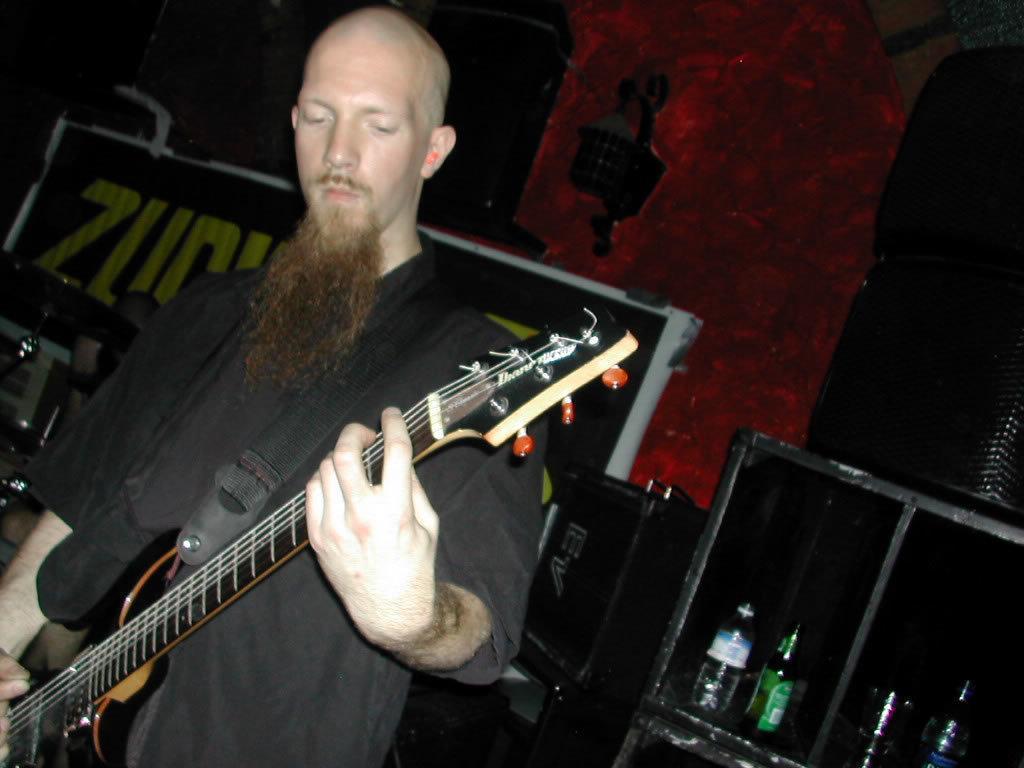Describe this image in one or two sentences. A man with black t-shirt is standing and playing a guitar. To the right bottom there is a cupboard with bottles in it. On the cupboard there are 2 speakers. In the background there is a poster and a lamp. 